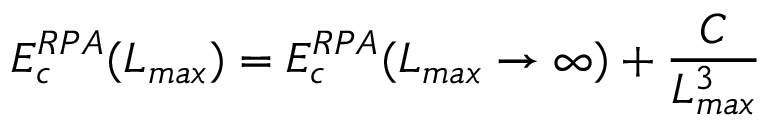<formula> <loc_0><loc_0><loc_500><loc_500>E _ { c } ^ { R P A } ( L _ { \max } ) = E _ { c } ^ { R P A } ( L _ { \max } \rightarrow { \infty } ) + \frac { C } { L _ { \max } ^ { 3 } }</formula> 